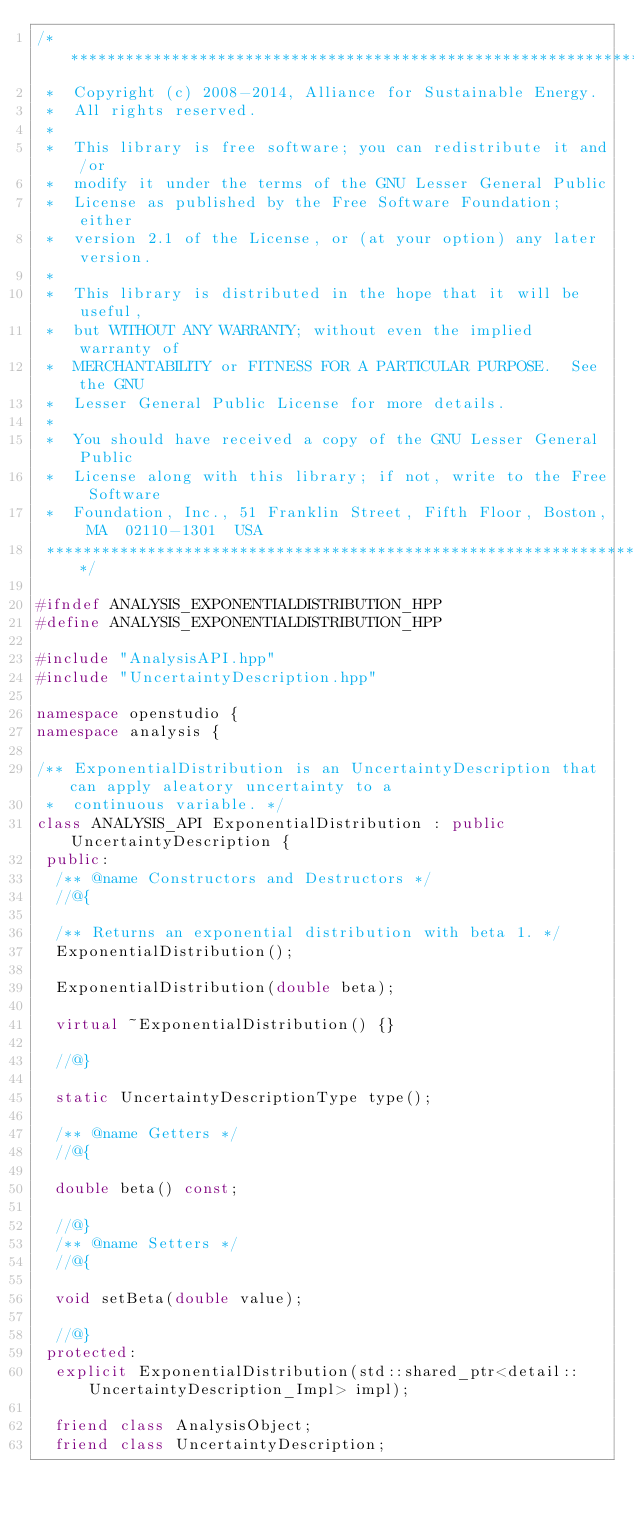<code> <loc_0><loc_0><loc_500><loc_500><_C++_>/**********************************************************************
 *  Copyright (c) 2008-2014, Alliance for Sustainable Energy.
 *  All rights reserved.
 *
 *  This library is free software; you can redistribute it and/or
 *  modify it under the terms of the GNU Lesser General Public
 *  License as published by the Free Software Foundation; either
 *  version 2.1 of the License, or (at your option) any later version.
 *
 *  This library is distributed in the hope that it will be useful,
 *  but WITHOUT ANY WARRANTY; without even the implied warranty of
 *  MERCHANTABILITY or FITNESS FOR A PARTICULAR PURPOSE.  See the GNU
 *  Lesser General Public License for more details.
 *
 *  You should have received a copy of the GNU Lesser General Public
 *  License along with this library; if not, write to the Free Software
 *  Foundation, Inc., 51 Franklin Street, Fifth Floor, Boston, MA  02110-1301  USA
 **********************************************************************/

#ifndef ANALYSIS_EXPONENTIALDISTRIBUTION_HPP
#define ANALYSIS_EXPONENTIALDISTRIBUTION_HPP

#include "AnalysisAPI.hpp"
#include "UncertaintyDescription.hpp"

namespace openstudio {
namespace analysis {

/** ExponentialDistribution is an UncertaintyDescription that can apply aleatory uncertainty to a
 *  continuous variable. */
class ANALYSIS_API ExponentialDistribution : public UncertaintyDescription {
 public:
  /** @name Constructors and Destructors */
  //@{

  /** Returns an exponential distribution with beta 1. */
  ExponentialDistribution();
   
  ExponentialDistribution(double beta);

  virtual ~ExponentialDistribution() {}

  //@}

  static UncertaintyDescriptionType type();

  /** @name Getters */
  //@{

  double beta() const;

  //@}
  /** @name Setters */
  //@{

  void setBeta(double value);

  //@}
 protected:
  explicit ExponentialDistribution(std::shared_ptr<detail::UncertaintyDescription_Impl> impl);

  friend class AnalysisObject;
  friend class UncertaintyDescription;</code> 